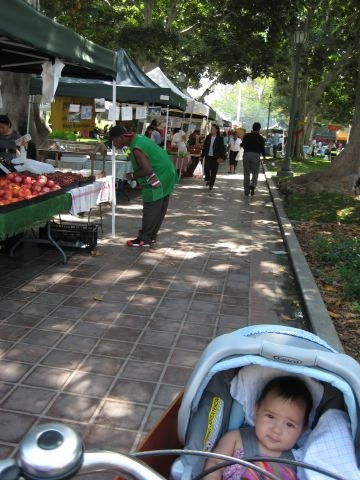Describe the objects in this image and their specific colors. I can see people in black and gray tones, bicycle in black, white, gray, and darkgray tones, people in black, darkgreen, and maroon tones, apple in black, maroon, and brown tones, and people in black, gray, and white tones in this image. 